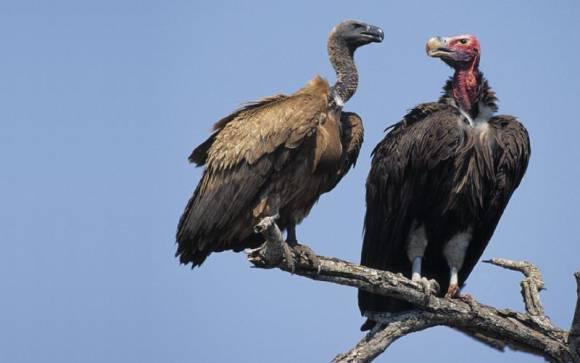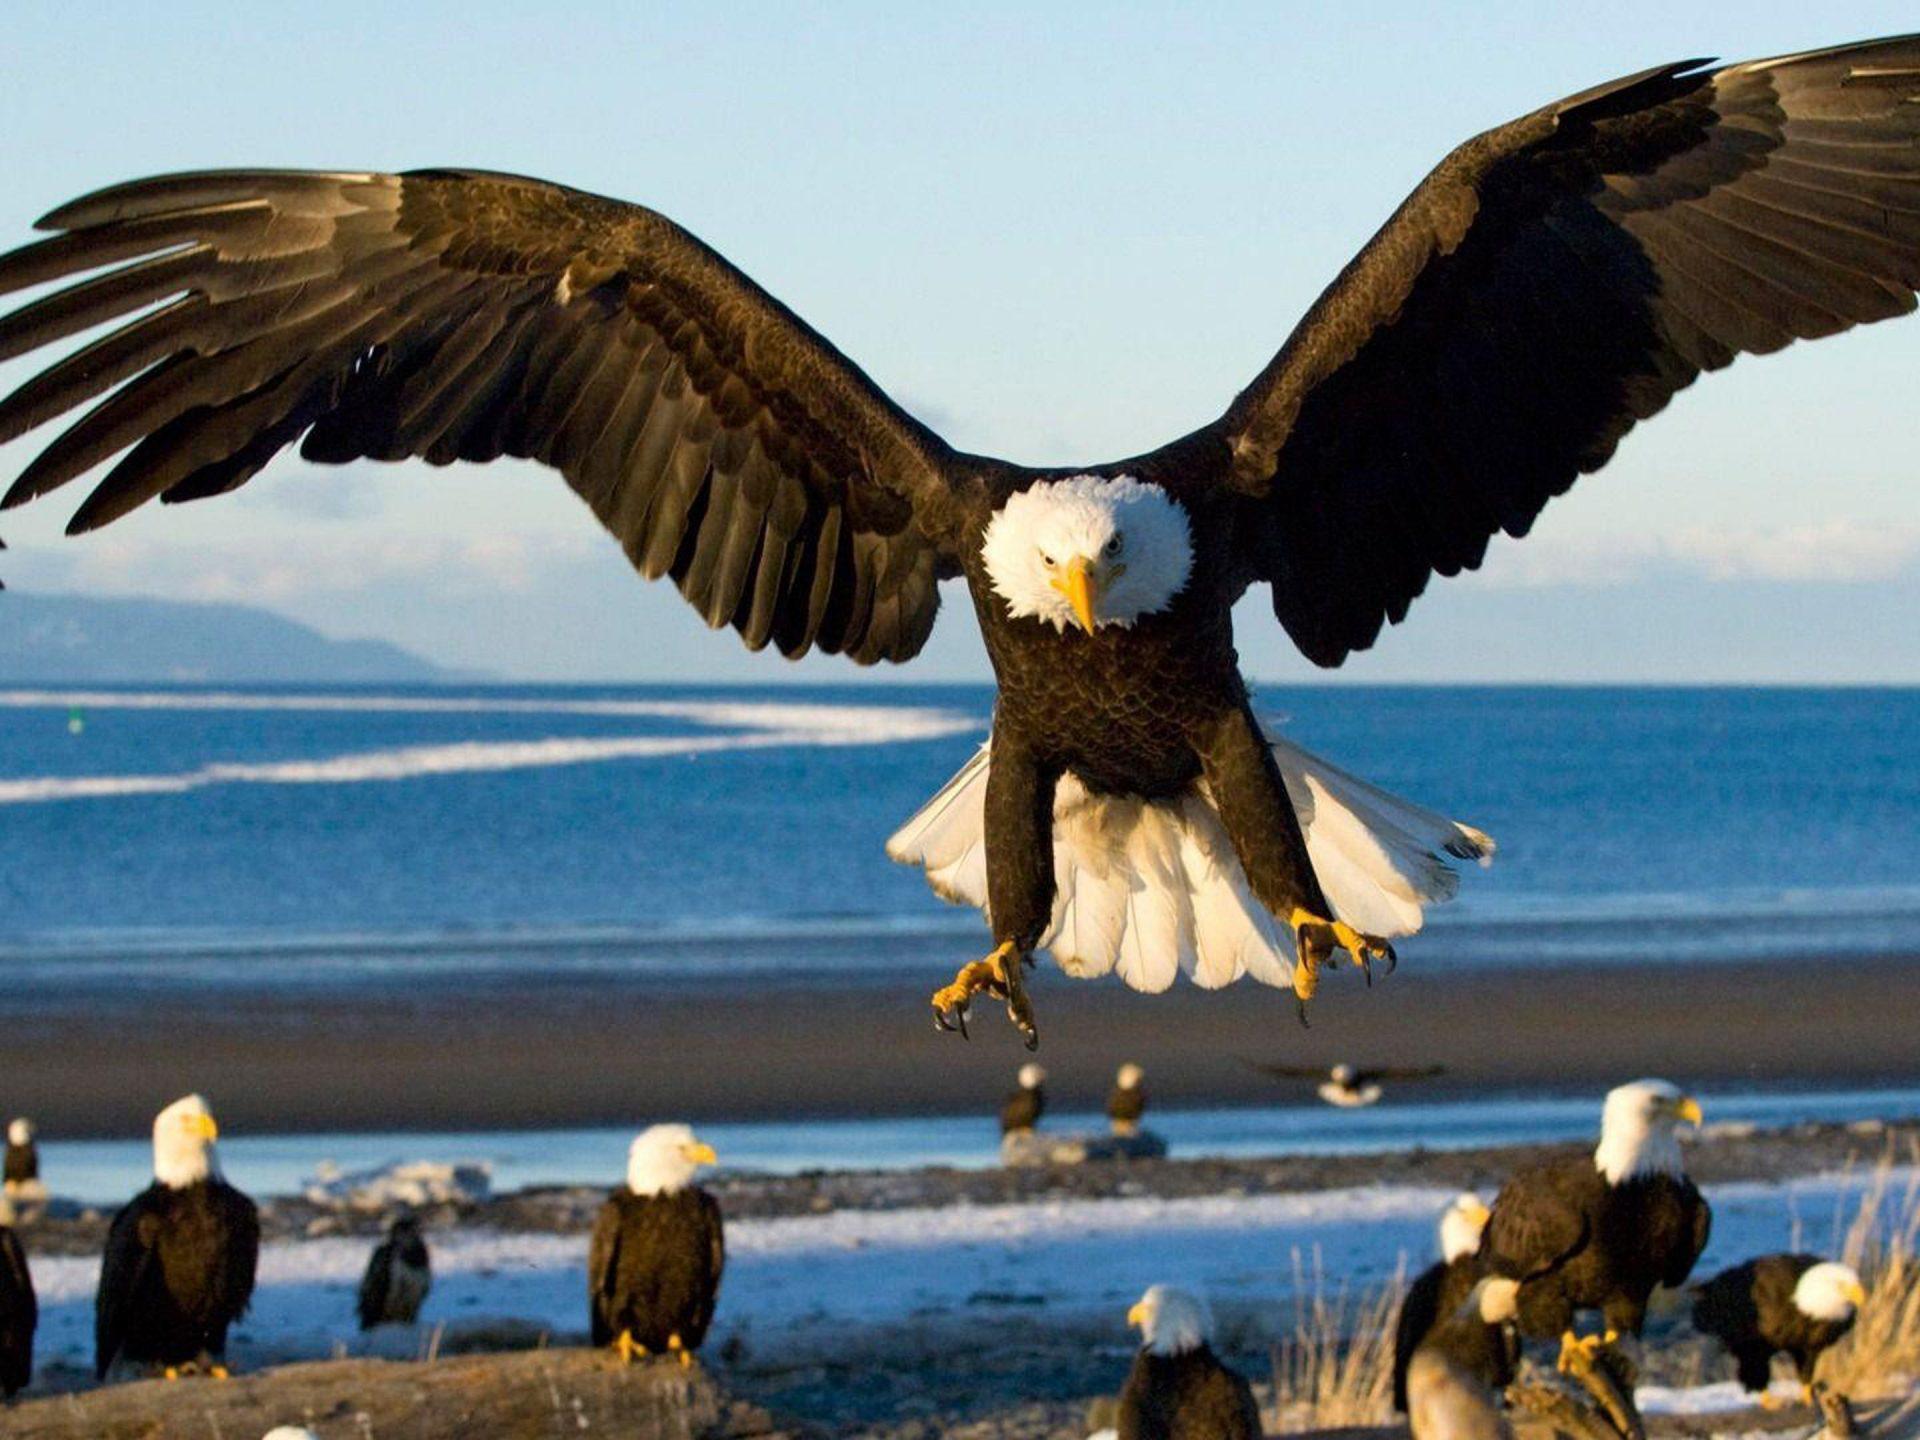The first image is the image on the left, the second image is the image on the right. Assess this claim about the two images: "The leftmost image in the pair is of a vulture, while the rightmost is of bald eagles.". Correct or not? Answer yes or no. Yes. The first image is the image on the left, the second image is the image on the right. Evaluate the accuracy of this statement regarding the images: "One of the images shows exactly one bald eagle with wings spread.". Is it true? Answer yes or no. Yes. 